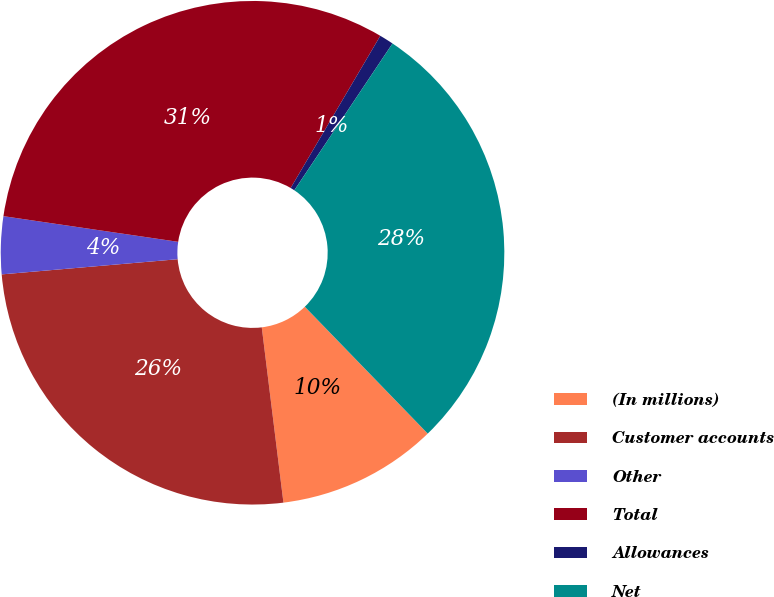Convert chart. <chart><loc_0><loc_0><loc_500><loc_500><pie_chart><fcel>(In millions)<fcel>Customer accounts<fcel>Other<fcel>Total<fcel>Allowances<fcel>Net<nl><fcel>10.29%<fcel>25.59%<fcel>3.69%<fcel>31.15%<fcel>0.91%<fcel>28.37%<nl></chart> 